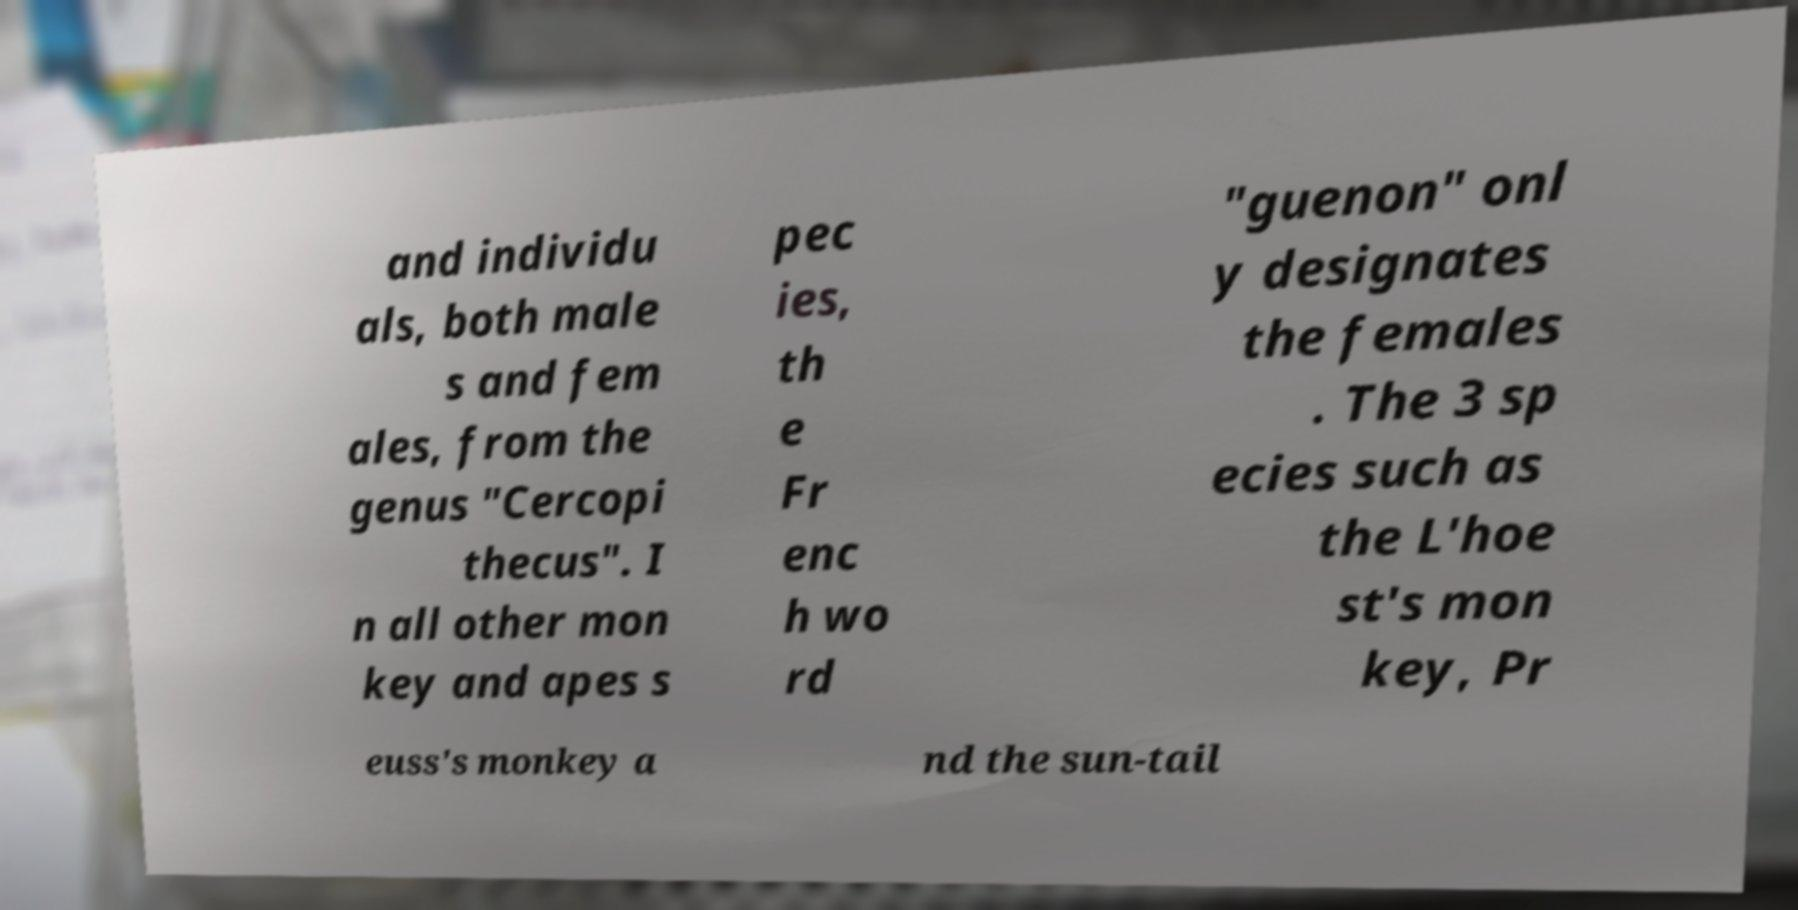Can you read and provide the text displayed in the image?This photo seems to have some interesting text. Can you extract and type it out for me? and individu als, both male s and fem ales, from the genus "Cercopi thecus". I n all other mon key and apes s pec ies, th e Fr enc h wo rd "guenon" onl y designates the females . The 3 sp ecies such as the L'hoe st's mon key, Pr euss's monkey a nd the sun-tail 